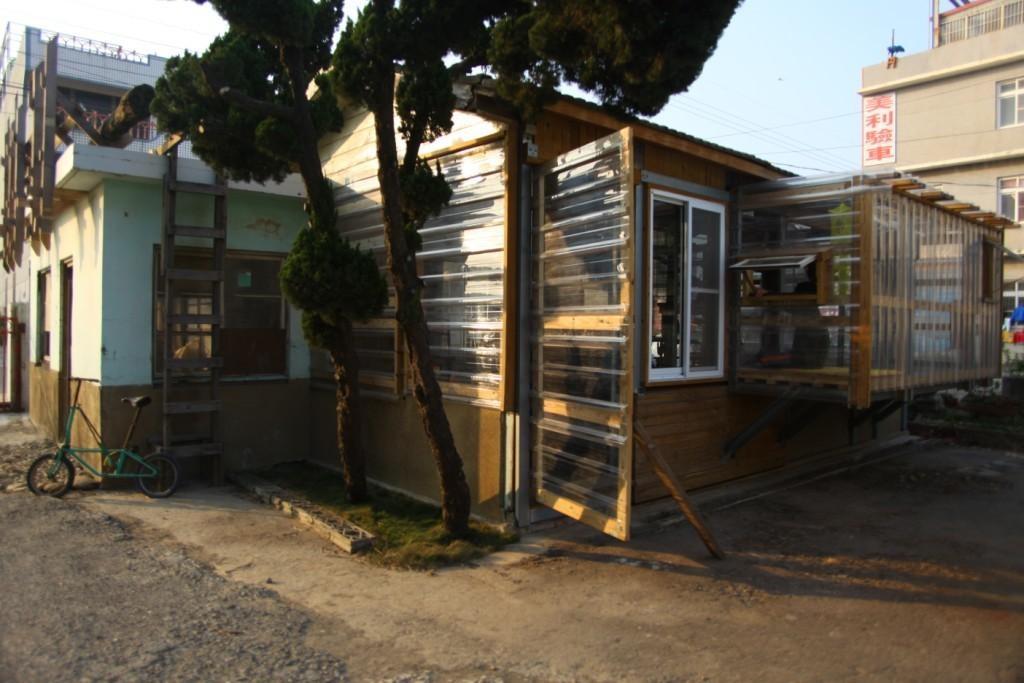What can be seen on the left side of the image? There is a bicycle and a ladder leading to a building on the left side of the image. What type of structures are visible in the image? There are buildings visible in the image. What can be seen along the path in the image? There are trees present along a path in the image. Where is the book located in the image? There is no book present in the image. What type of bat can be seen flying near the trees in the image? There are no bats visible in the image; only a bicycle, a ladder, buildings, and trees are present. 